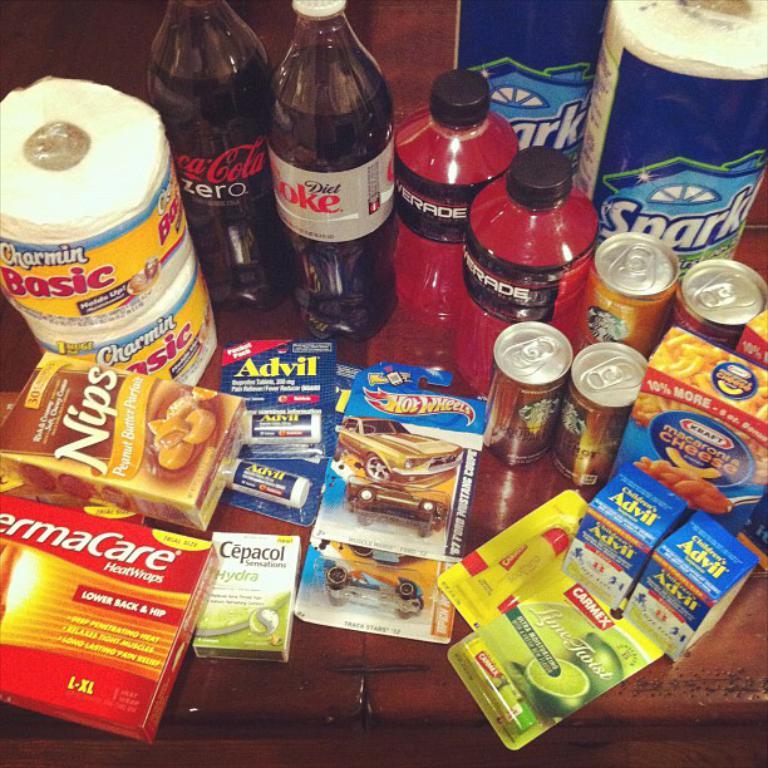What is the red drink?
Keep it short and to the point. Powerade. What brand of toy car is that?
Make the answer very short. Hot wheels. 